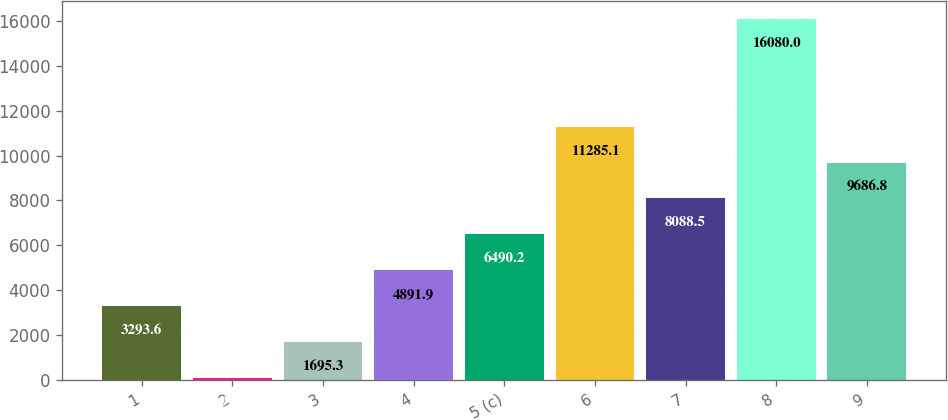Convert chart to OTSL. <chart><loc_0><loc_0><loc_500><loc_500><bar_chart><fcel>1<fcel>2<fcel>3<fcel>4<fcel>5 (c)<fcel>6<fcel>7<fcel>8<fcel>9<nl><fcel>3293.6<fcel>97<fcel>1695.3<fcel>4891.9<fcel>6490.2<fcel>11285.1<fcel>8088.5<fcel>16080<fcel>9686.8<nl></chart> 